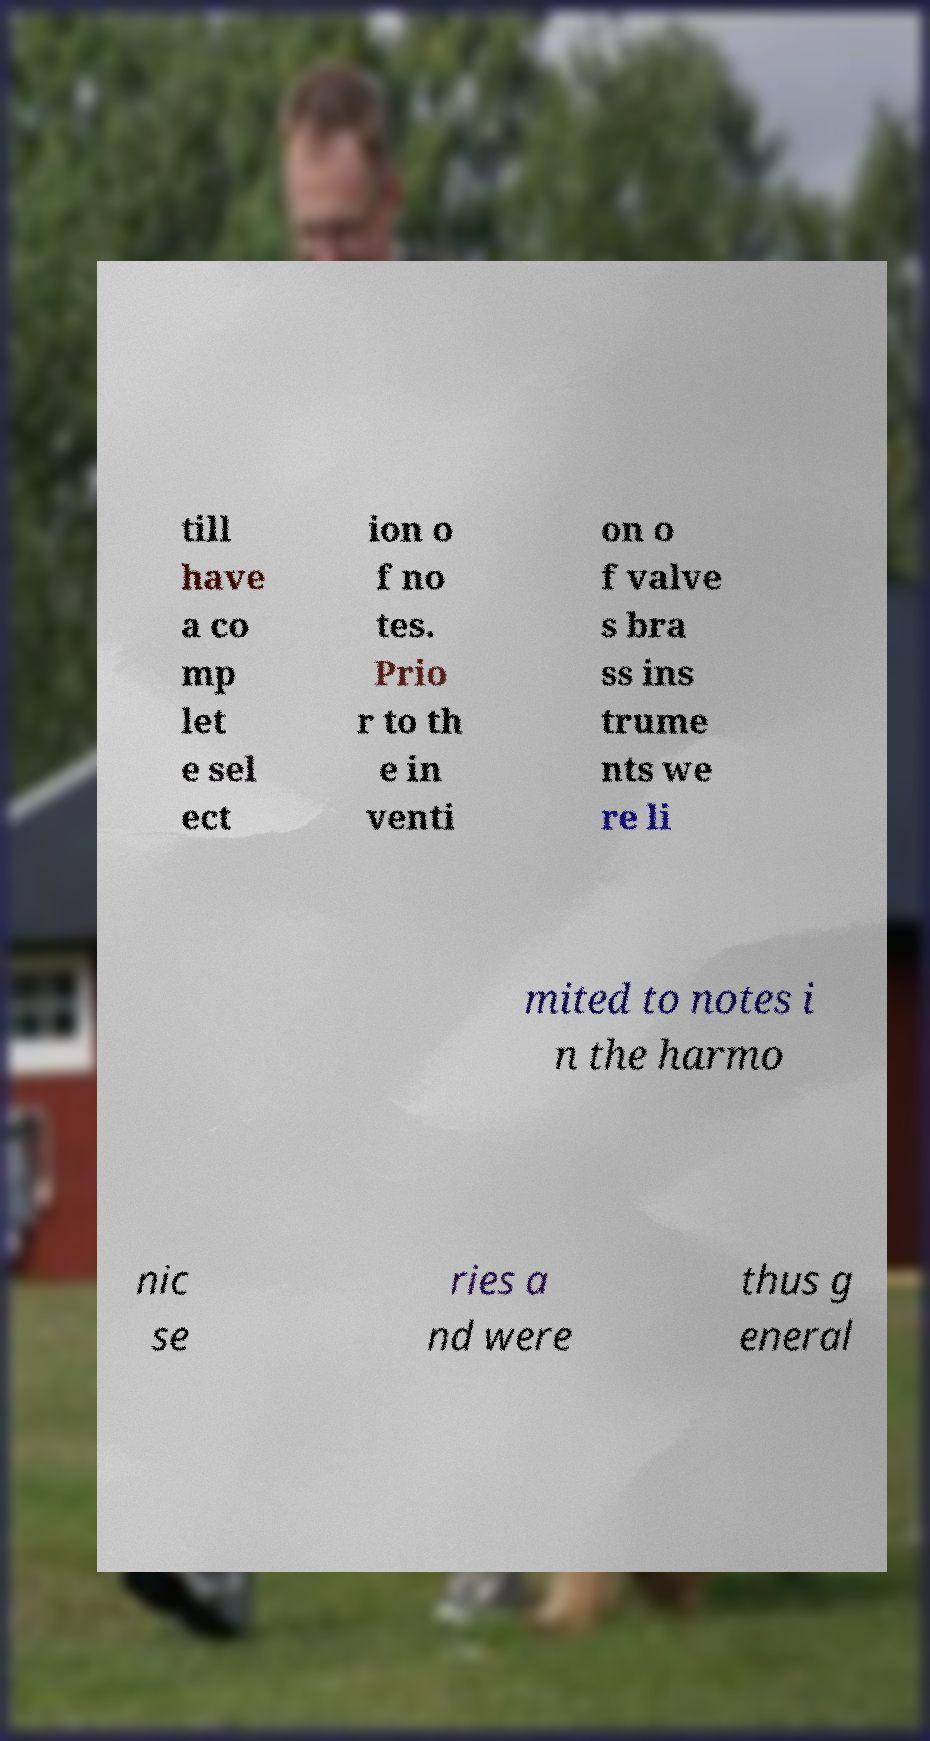Please read and relay the text visible in this image. What does it say? till have a co mp let e sel ect ion o f no tes. Prio r to th e in venti on o f valve s bra ss ins trume nts we re li mited to notes i n the harmo nic se ries a nd were thus g eneral 